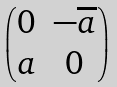<formula> <loc_0><loc_0><loc_500><loc_500>\begin{pmatrix} 0 & - \overline { a } \\ a & 0 \end{pmatrix}</formula> 